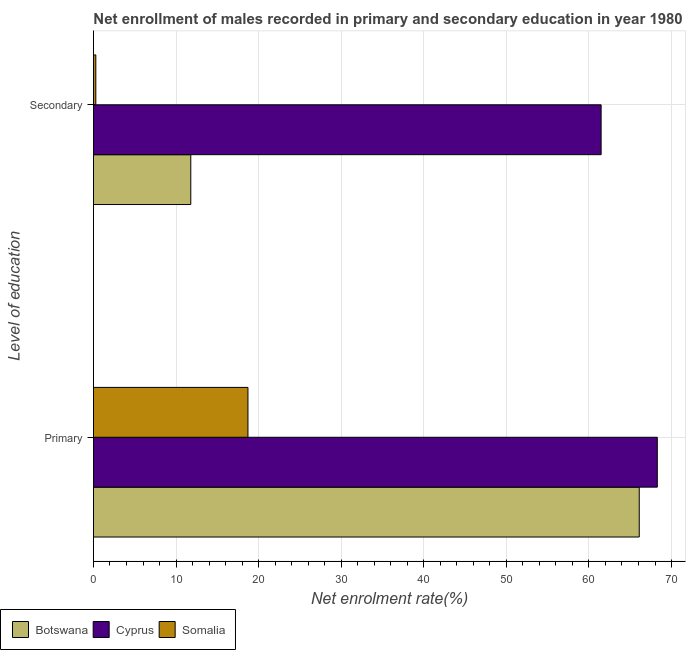How many groups of bars are there?
Ensure brevity in your answer.  2. Are the number of bars per tick equal to the number of legend labels?
Provide a succinct answer. Yes. Are the number of bars on each tick of the Y-axis equal?
Your answer should be compact. Yes. What is the label of the 1st group of bars from the top?
Your answer should be very brief. Secondary. What is the enrollment rate in primary education in Cyprus?
Give a very brief answer. 68.28. Across all countries, what is the maximum enrollment rate in secondary education?
Keep it short and to the point. 61.48. Across all countries, what is the minimum enrollment rate in primary education?
Offer a terse response. 18.71. In which country was the enrollment rate in primary education maximum?
Give a very brief answer. Cyprus. In which country was the enrollment rate in primary education minimum?
Provide a succinct answer. Somalia. What is the total enrollment rate in secondary education in the graph?
Provide a succinct answer. 73.54. What is the difference between the enrollment rate in secondary education in Botswana and that in Cyprus?
Provide a short and direct response. -49.69. What is the difference between the enrollment rate in secondary education in Somalia and the enrollment rate in primary education in Botswana?
Provide a succinct answer. -65.81. What is the average enrollment rate in primary education per country?
Ensure brevity in your answer.  51.03. What is the difference between the enrollment rate in primary education and enrollment rate in secondary education in Somalia?
Provide a short and direct response. 18.42. What is the ratio of the enrollment rate in primary education in Somalia to that in Cyprus?
Give a very brief answer. 0.27. Is the enrollment rate in secondary education in Cyprus less than that in Somalia?
Offer a very short reply. No. What does the 2nd bar from the top in Secondary represents?
Offer a very short reply. Cyprus. What does the 3rd bar from the bottom in Secondary represents?
Ensure brevity in your answer.  Somalia. What is the difference between two consecutive major ticks on the X-axis?
Your answer should be very brief. 10. Are the values on the major ticks of X-axis written in scientific E-notation?
Provide a short and direct response. No. Does the graph contain grids?
Give a very brief answer. Yes. Where does the legend appear in the graph?
Give a very brief answer. Bottom left. How are the legend labels stacked?
Your answer should be very brief. Horizontal. What is the title of the graph?
Provide a succinct answer. Net enrollment of males recorded in primary and secondary education in year 1980. What is the label or title of the X-axis?
Offer a very short reply. Net enrolment rate(%). What is the label or title of the Y-axis?
Your response must be concise. Level of education. What is the Net enrolment rate(%) in Botswana in Primary?
Your answer should be very brief. 66.09. What is the Net enrolment rate(%) in Cyprus in Primary?
Give a very brief answer. 68.28. What is the Net enrolment rate(%) in Somalia in Primary?
Provide a short and direct response. 18.71. What is the Net enrolment rate(%) in Botswana in Secondary?
Your answer should be very brief. 11.78. What is the Net enrolment rate(%) in Cyprus in Secondary?
Provide a succinct answer. 61.48. What is the Net enrolment rate(%) in Somalia in Secondary?
Provide a succinct answer. 0.28. Across all Level of education, what is the maximum Net enrolment rate(%) in Botswana?
Your response must be concise. 66.09. Across all Level of education, what is the maximum Net enrolment rate(%) in Cyprus?
Provide a short and direct response. 68.28. Across all Level of education, what is the maximum Net enrolment rate(%) of Somalia?
Give a very brief answer. 18.71. Across all Level of education, what is the minimum Net enrolment rate(%) in Botswana?
Your answer should be very brief. 11.78. Across all Level of education, what is the minimum Net enrolment rate(%) in Cyprus?
Your response must be concise. 61.48. Across all Level of education, what is the minimum Net enrolment rate(%) in Somalia?
Ensure brevity in your answer.  0.28. What is the total Net enrolment rate(%) in Botswana in the graph?
Make the answer very short. 77.88. What is the total Net enrolment rate(%) in Cyprus in the graph?
Offer a terse response. 129.75. What is the total Net enrolment rate(%) in Somalia in the graph?
Keep it short and to the point. 18.99. What is the difference between the Net enrolment rate(%) in Botswana in Primary and that in Secondary?
Offer a very short reply. 54.31. What is the difference between the Net enrolment rate(%) in Cyprus in Primary and that in Secondary?
Give a very brief answer. 6.8. What is the difference between the Net enrolment rate(%) in Somalia in Primary and that in Secondary?
Your answer should be very brief. 18.42. What is the difference between the Net enrolment rate(%) in Botswana in Primary and the Net enrolment rate(%) in Cyprus in Secondary?
Make the answer very short. 4.62. What is the difference between the Net enrolment rate(%) of Botswana in Primary and the Net enrolment rate(%) of Somalia in Secondary?
Make the answer very short. 65.81. What is the difference between the Net enrolment rate(%) in Cyprus in Primary and the Net enrolment rate(%) in Somalia in Secondary?
Your answer should be compact. 67.99. What is the average Net enrolment rate(%) in Botswana per Level of education?
Give a very brief answer. 38.94. What is the average Net enrolment rate(%) in Cyprus per Level of education?
Offer a very short reply. 64.88. What is the average Net enrolment rate(%) of Somalia per Level of education?
Make the answer very short. 9.5. What is the difference between the Net enrolment rate(%) in Botswana and Net enrolment rate(%) in Cyprus in Primary?
Offer a very short reply. -2.19. What is the difference between the Net enrolment rate(%) of Botswana and Net enrolment rate(%) of Somalia in Primary?
Your answer should be very brief. 47.39. What is the difference between the Net enrolment rate(%) of Cyprus and Net enrolment rate(%) of Somalia in Primary?
Your answer should be compact. 49.57. What is the difference between the Net enrolment rate(%) in Botswana and Net enrolment rate(%) in Cyprus in Secondary?
Offer a very short reply. -49.69. What is the difference between the Net enrolment rate(%) of Botswana and Net enrolment rate(%) of Somalia in Secondary?
Offer a terse response. 11.5. What is the difference between the Net enrolment rate(%) in Cyprus and Net enrolment rate(%) in Somalia in Secondary?
Make the answer very short. 61.19. What is the ratio of the Net enrolment rate(%) in Botswana in Primary to that in Secondary?
Provide a short and direct response. 5.61. What is the ratio of the Net enrolment rate(%) in Cyprus in Primary to that in Secondary?
Make the answer very short. 1.11. What is the ratio of the Net enrolment rate(%) of Somalia in Primary to that in Secondary?
Ensure brevity in your answer.  65.87. What is the difference between the highest and the second highest Net enrolment rate(%) of Botswana?
Keep it short and to the point. 54.31. What is the difference between the highest and the second highest Net enrolment rate(%) in Cyprus?
Give a very brief answer. 6.8. What is the difference between the highest and the second highest Net enrolment rate(%) in Somalia?
Give a very brief answer. 18.42. What is the difference between the highest and the lowest Net enrolment rate(%) in Botswana?
Offer a terse response. 54.31. What is the difference between the highest and the lowest Net enrolment rate(%) of Cyprus?
Your response must be concise. 6.8. What is the difference between the highest and the lowest Net enrolment rate(%) in Somalia?
Keep it short and to the point. 18.42. 